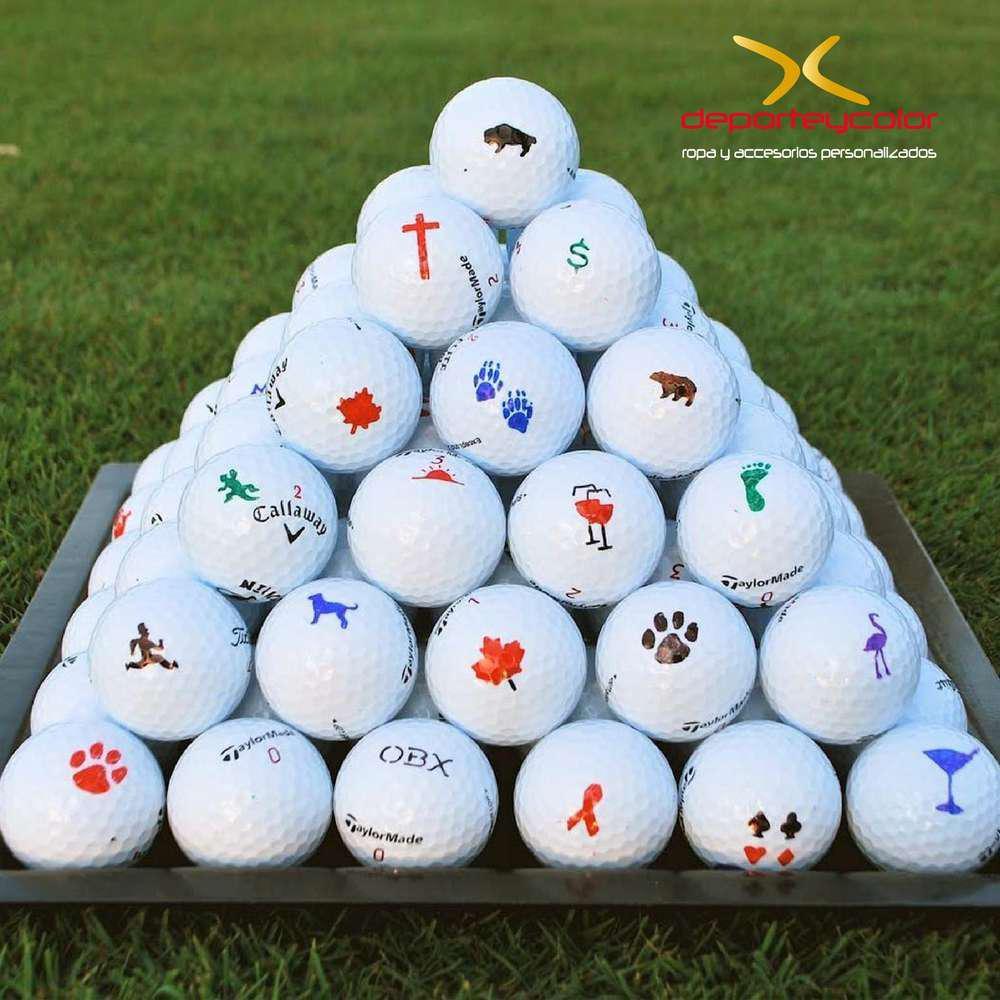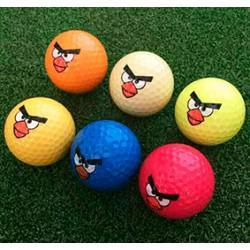The first image is the image on the left, the second image is the image on the right. For the images displayed, is the sentence "There is an open ball with something inside it in the left image, but not in the right." factually correct? Answer yes or no. No. 